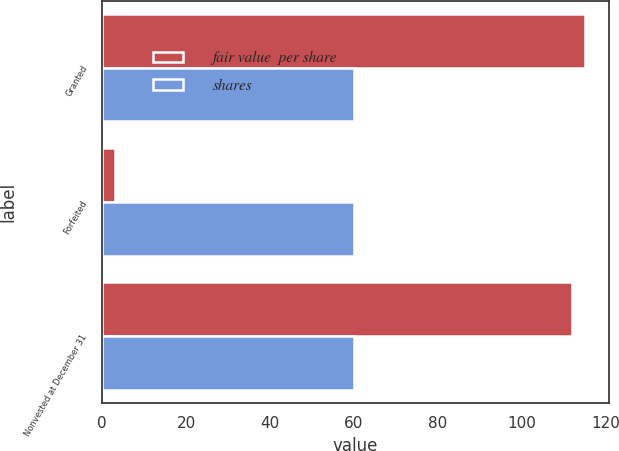Convert chart to OTSL. <chart><loc_0><loc_0><loc_500><loc_500><stacked_bar_chart><ecel><fcel>Granted<fcel>Forfeited<fcel>Nonvested at December 31<nl><fcel>fair value  per share<fcel>115<fcel>3<fcel>112<nl><fcel>shares<fcel>60<fcel>60<fcel>60<nl></chart> 